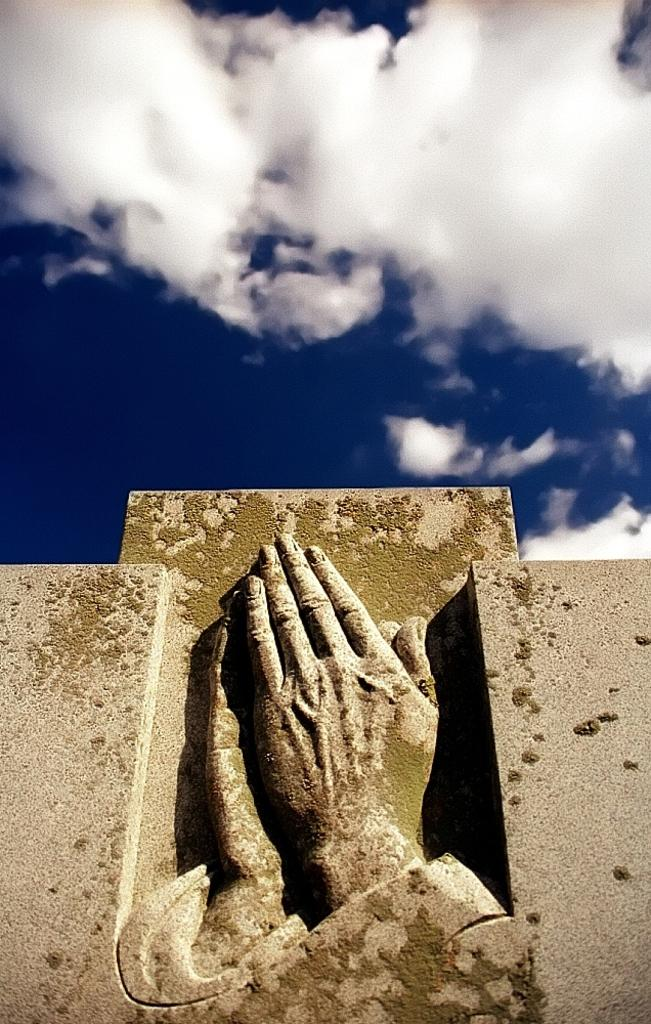What is located at the bottom of the image? There is a sculpture and a wall at the bottom of the image. What can be seen above the sculpture and wall in the image? The sky is visible at the top of the image. Can you hear the sound of a cough in the image? There is no sound or indication of a cough in the image, as it is a static visual representation. What type of event is taking place in the image? There is no event depicted in the image; it features a sculpture, a wall, and the sky. 